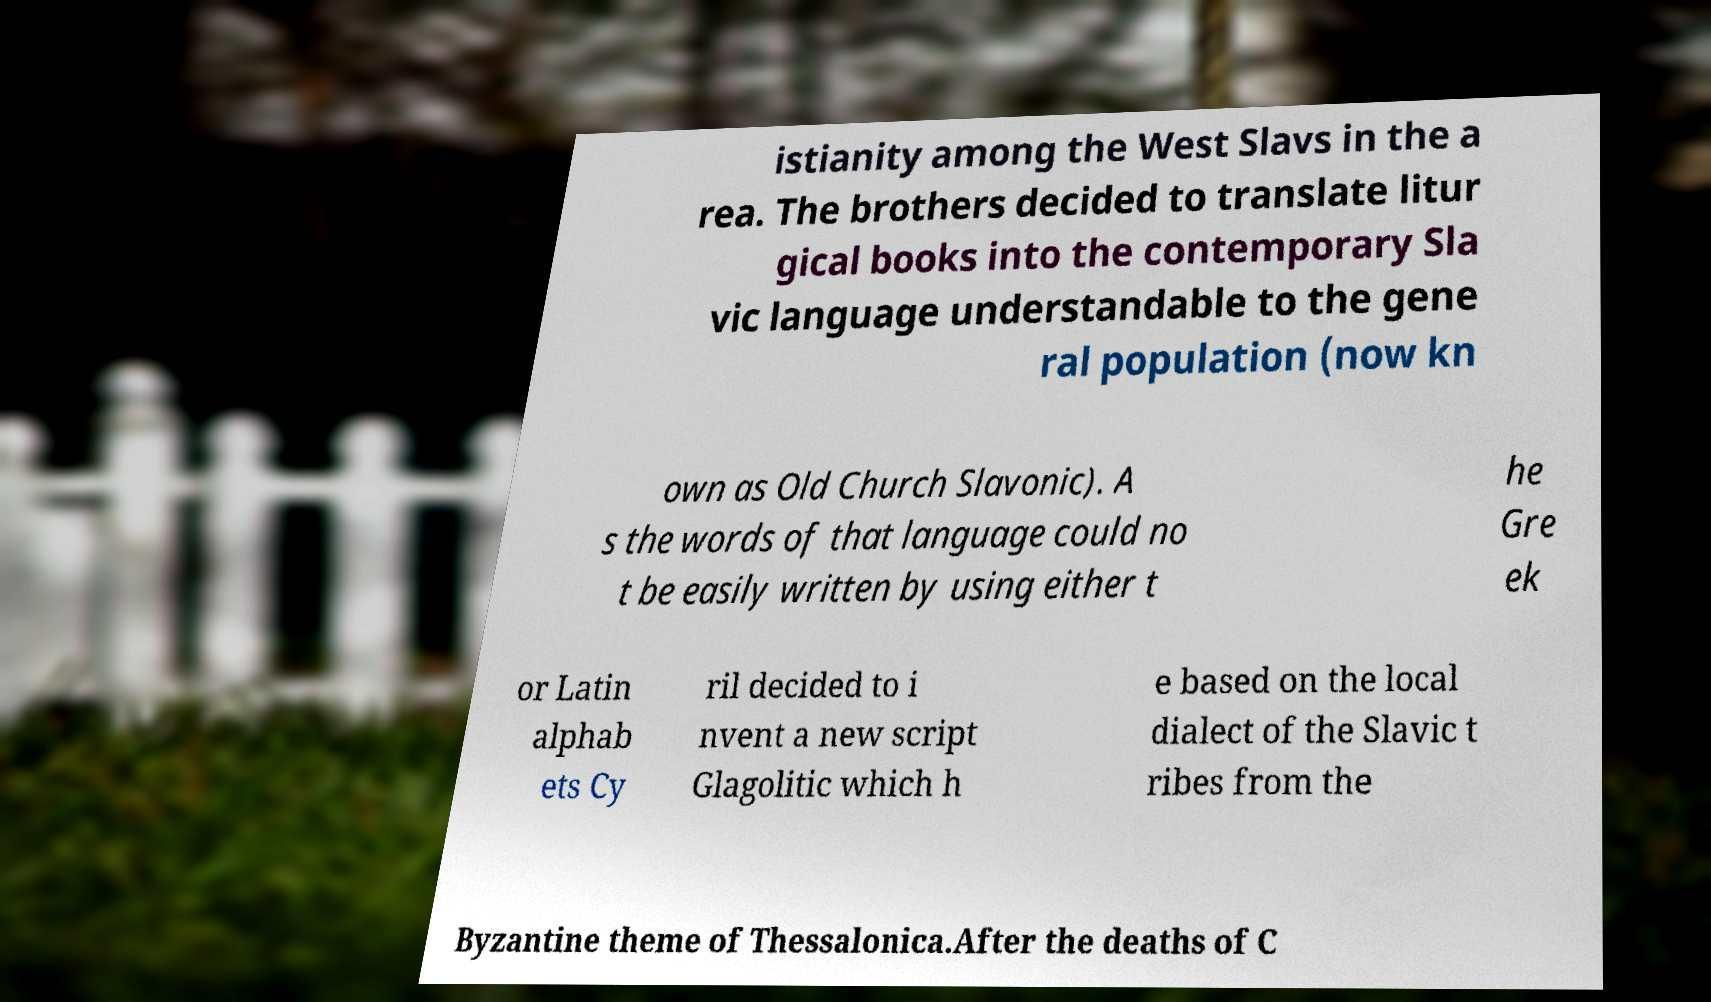Could you assist in decoding the text presented in this image and type it out clearly? istianity among the West Slavs in the a rea. The brothers decided to translate litur gical books into the contemporary Sla vic language understandable to the gene ral population (now kn own as Old Church Slavonic). A s the words of that language could no t be easily written by using either t he Gre ek or Latin alphab ets Cy ril decided to i nvent a new script Glagolitic which h e based on the local dialect of the Slavic t ribes from the Byzantine theme of Thessalonica.After the deaths of C 